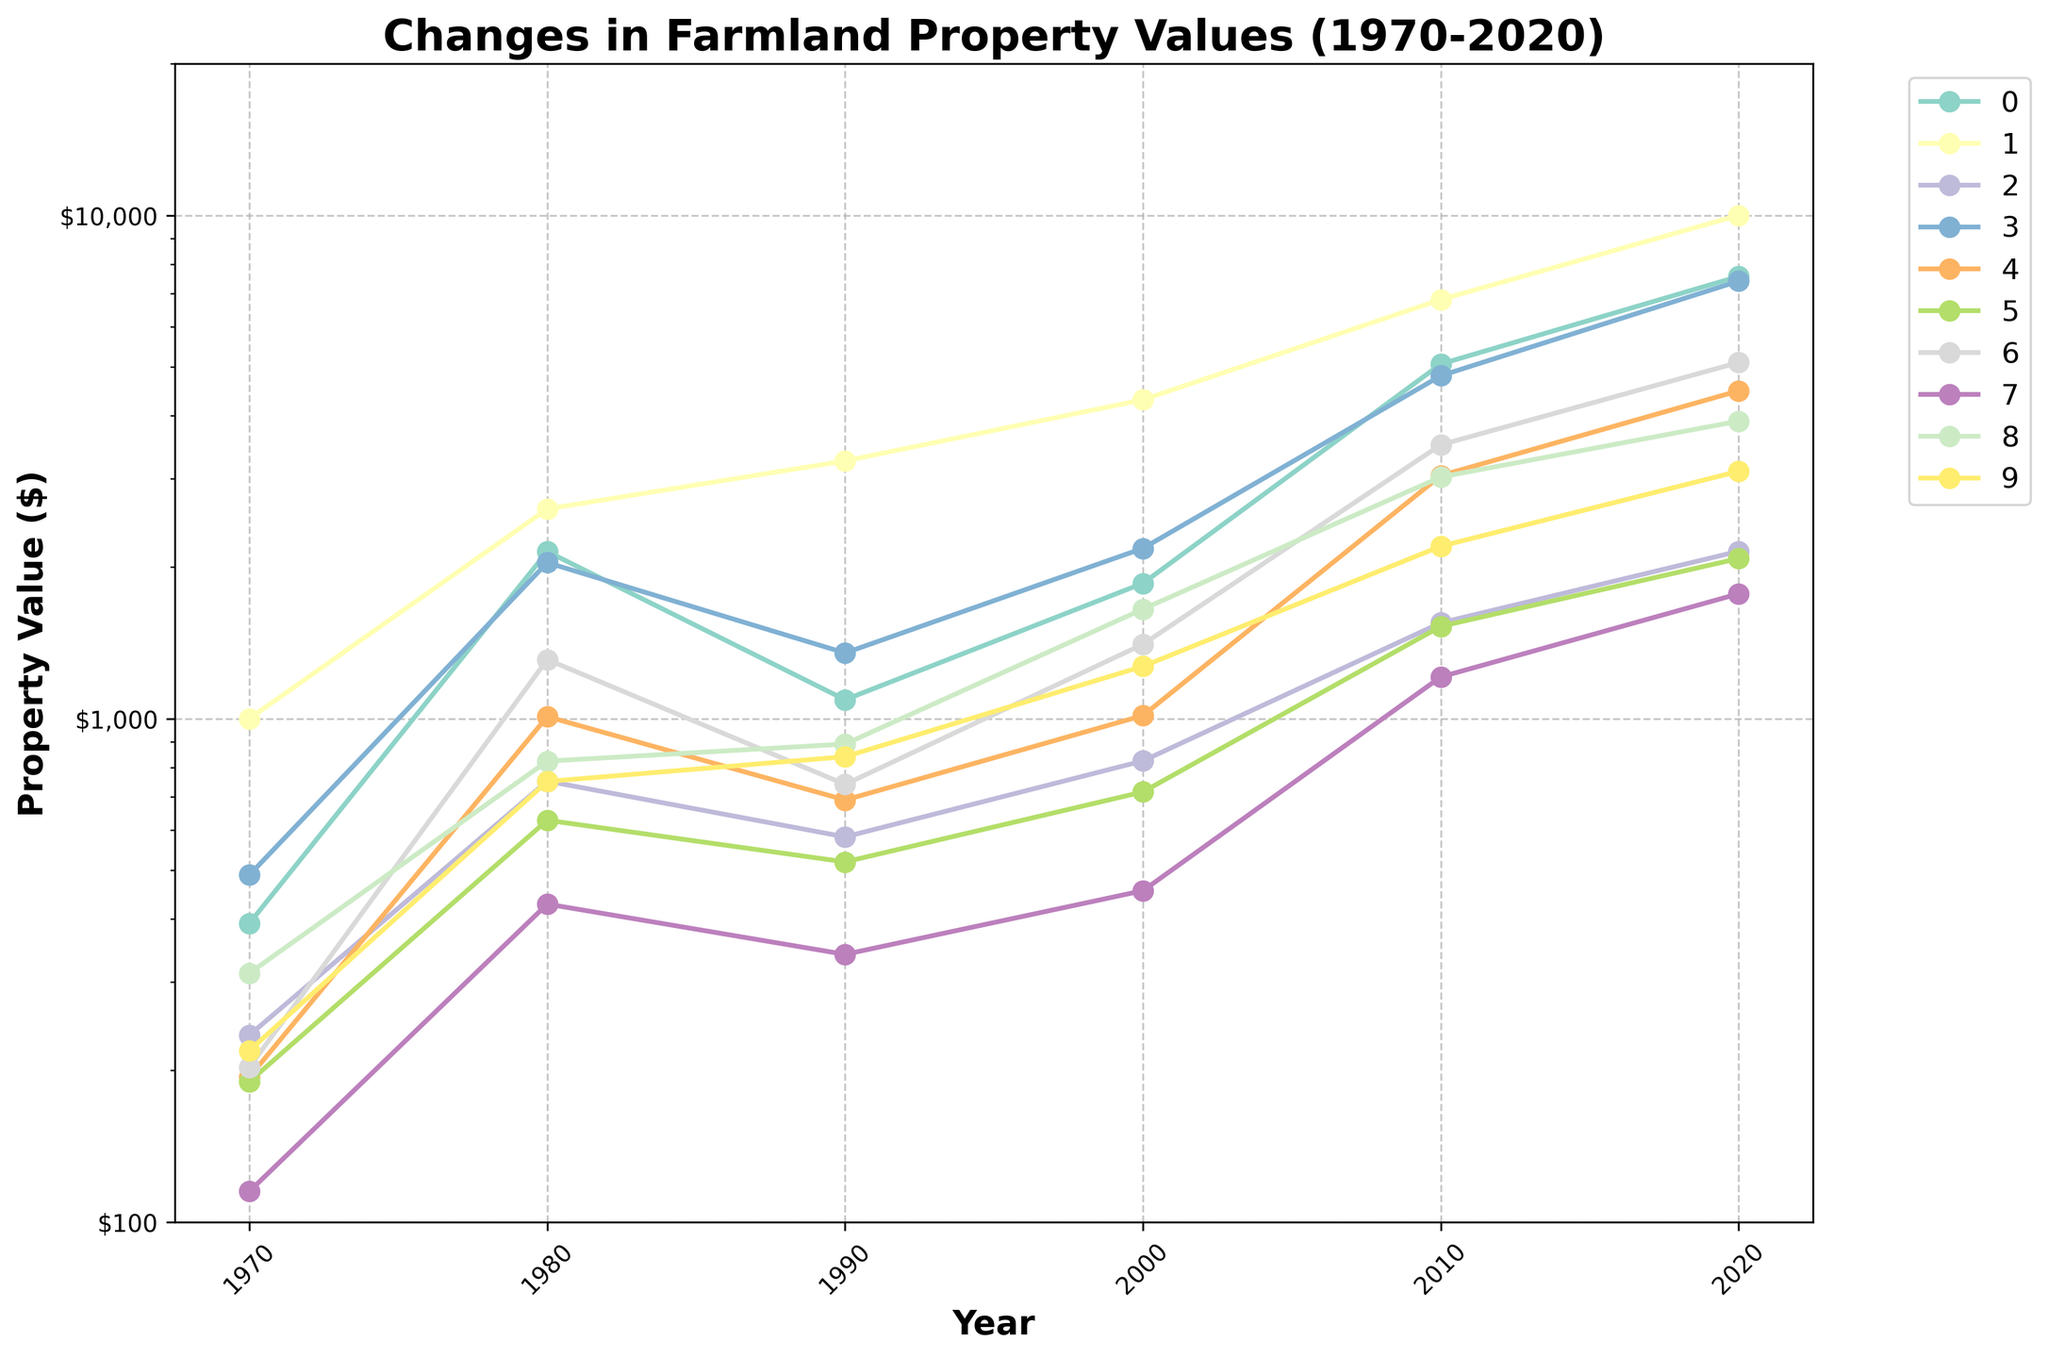What is the general trend in farmland property values from 1970 to 2020 across the regions? By looking at the plot, it's clear that the property values in almost all regions show an increasing trend over the years. Some regions have steeper increases than others.
Answer: Increasing Which region had the highest property value in 2020? By observing the highest point on the rightmost side of the plot and matching it with the legend, California had the highest property value in 2020.
Answer: California Which two regions had the most similar property values in 1980? By comparing the 1980 data points across the regions on the plot, Illinois and Iowa appear to have very close values around that year.
Answer: Illinois, Iowa How did Nebraska's property values change between 1970 and 2020? Nebraska's property values are plotted between $194 in 1970 and $4480 in 2020. The property values show a significant increase over this period.
Answer: Increased Between 2000 and 2010, which region experienced the most significant percentage increase in property value? To find this, one would need to compare the percentage increase for each region: (Value in 2010 - Value in 2000) / Value in 2000. On visual inspection, Iowa appears to have a significant percentage increase.
Answer: Iowa On a log scale, which region showed the least change in property value from 1970 to 2020? By observing the lines that are the most horizontal over the entire period, Texas and Kansas show the least change in property value.
Answer: Texas, Kansas Compare the property values between Illinois and Georgia in 2020 and find the difference. Illinois had a value of $7400, and Georgia had $3900 in 2020. The difference is $7400 - $3900.
Answer: $3500 Which region had the highest rate of increase in property values between 2010 to 2020? By assessing the steepness of the lines between 2010 and 2020, California shows the steepest incline, indicating the highest rate of increase.
Answer: California In which decade did Minnesota experience the biggest jump in property values? By comparing the slopes of Minnesota’s line segment per decade, the steepest slope appears between 2010 and 2020.
Answer: 2010-2020 What is the average property value for Iowa across all listed years (1970, 1980, 1990, 2000, 2010, 2020)? Add all the property values for Iowa ($392 + $2147 + $1090 + $1857 + $5064 + $7559) and divide by 6. The average is (392 + 2147 + 1090 + 1857 + 5064 + 7559) / 6.
Answer: $3018.17 